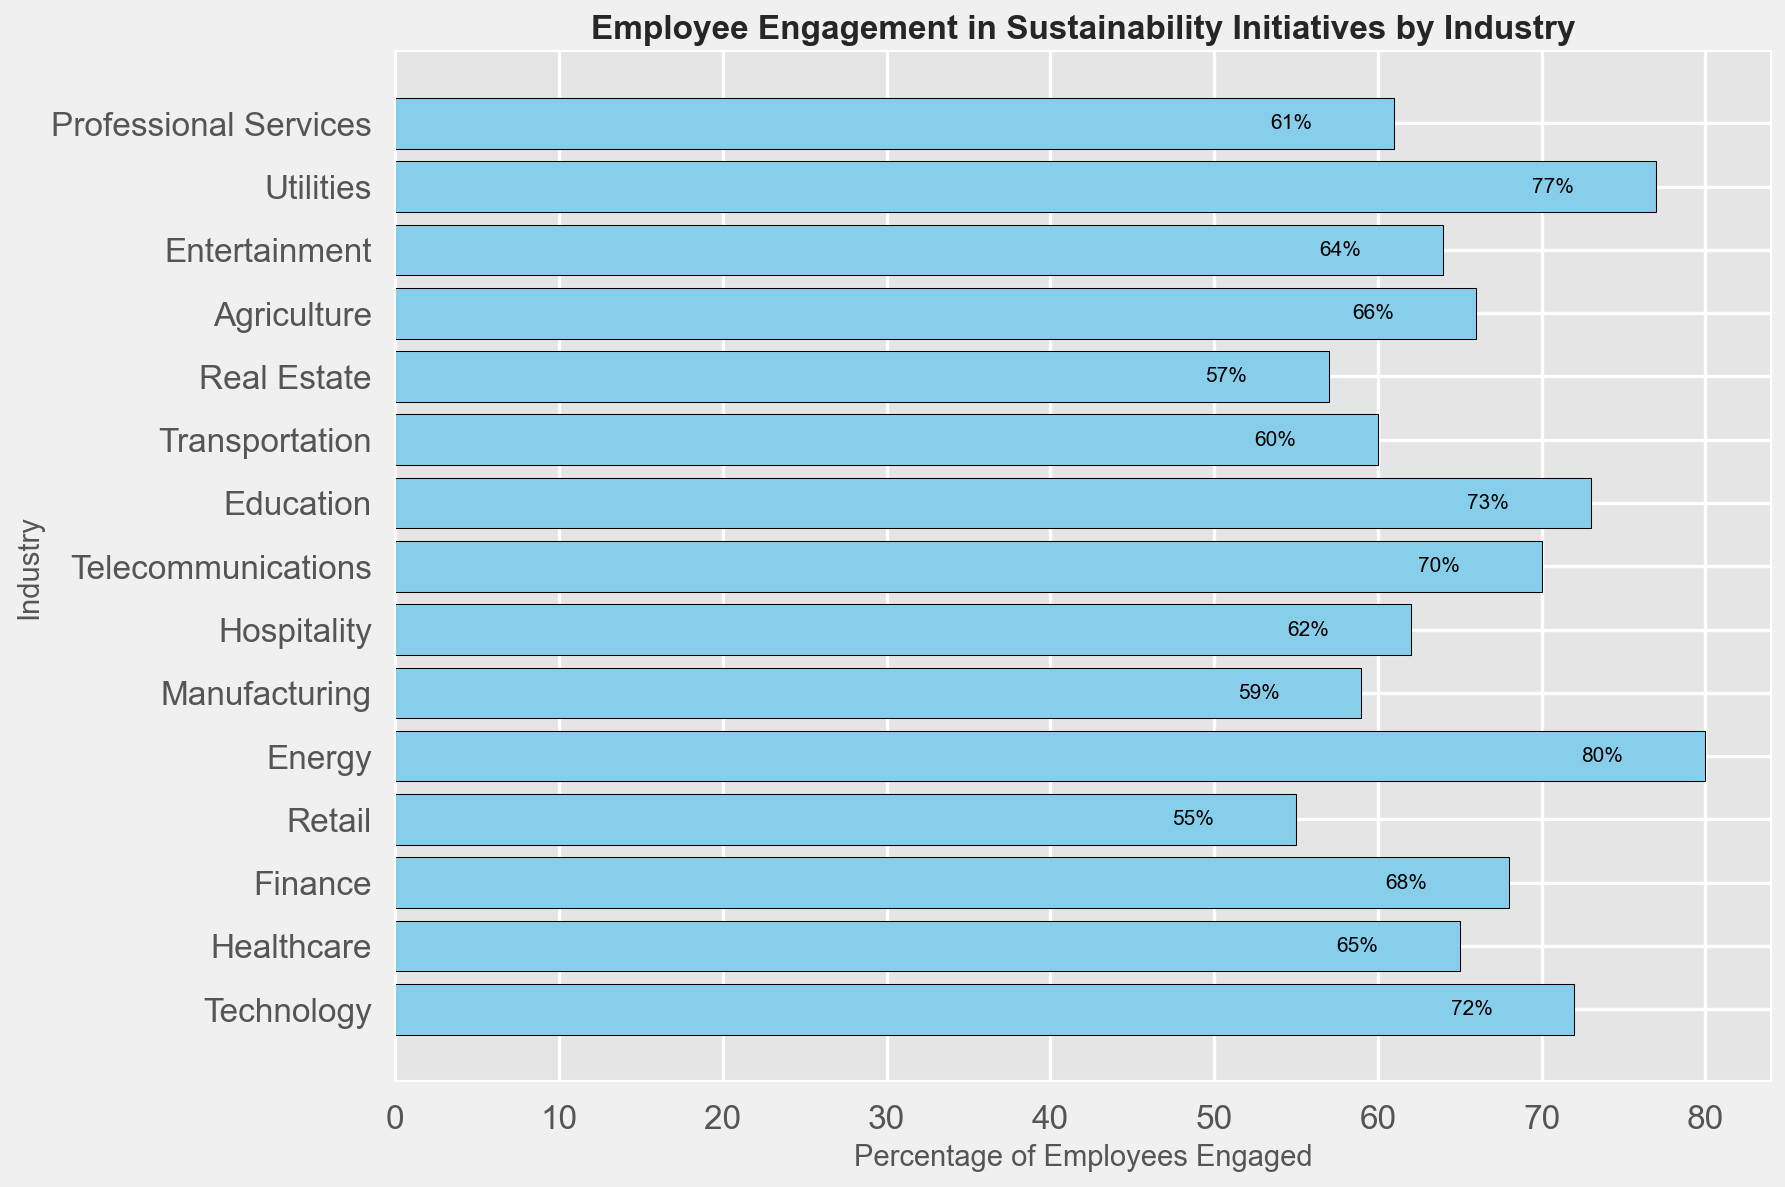What industry has the highest percentage of employees engaged in sustainability initiatives? According to the bar chart, Energy has the highest percentage of employees engaged in sustainability initiatives at 80%.
Answer: Energy Which industry has a higher engagement in sustainability initiatives, Telecommunications or Healthcare? Comparing the bars, Telecommunications has 70% while Healthcare has 65%, so Telecommunications has higher engagement.
Answer: Telecommunications Calculate the average percentage of employee engagement in sustainability initiatives across all the industries presented. Add the engagement percentages: 72 + 65 + 68 + 55 + 80 + 59 + 62 + 70 + 73 + 60 + 57 + 66 + 64 + 77 + 61 = 989. Divide by the number of industries, which is 15: 989 / 15 ≈ 65.93.
Answer: 65.93 Is the employee engagement in sustainability initiatives for Manufacturing higher or lower than the average engagement across all industries? The Manufacturing industry has an engagement of 59%. The average engagement across all industries is approximately 65.93%. Since 59 is less than 65.93, Manufacturing is lower than average.
Answer: Lower Compare the employee engagement percentages in the Energy and Utilities industries and state which is higher. The Energy industry has 80% engagement, whereas the Utilities industry has 77% engagement. Comparing these, Energy has a higher engagement percentage than Utilities.
Answer: Energy What is the difference in employee engagement between the highest and lowest industries? The highest engagement is in the Energy sector at 80%, and the lowest is in Retail at 55%. The difference is 80 - 55 = 25%.
Answer: 25% Which two industries have the most similar engagement percentages in sustainability initiatives? Agriculture and Healthcare have engagement percentages of 66% and 65%, respectively, showing the closest similarity.
Answer: Agriculture and Healthcare What are the combined employee engagement percentages for Technology, Healthcare, and Finance? Adding the engagement percentages gives 72 + 65 + 68 = 205%.
Answer: 205% What percentage of employee engagement in sustainability initiatives does Telecommunications have? From the bar chart, telecommunications has an engagement percentage of 70%.
Answer: 70% How does the employee engagement in the Professional Services industry compare to that in Retail? Professional Services has an engagement percentage of 61%, while Retail has 55%, making Professional Services higher.
Answer: Higher 